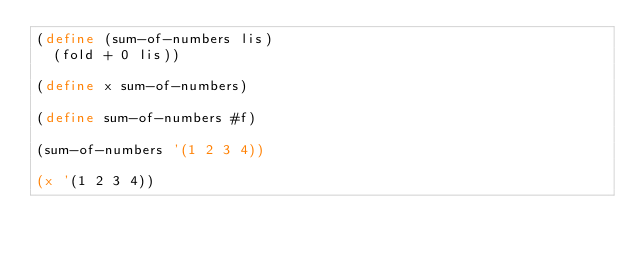Convert code to text. <code><loc_0><loc_0><loc_500><loc_500><_Scheme_>(define (sum-of-numbers lis)
  (fold + 0 lis))

(define x sum-of-numbers)

(define sum-of-numbers #f)

(sum-of-numbers '(1 2 3 4))

(x '(1 2 3 4))
</code> 